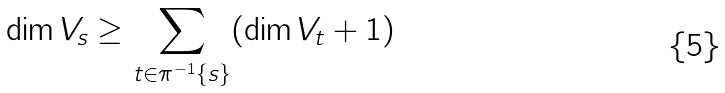<formula> <loc_0><loc_0><loc_500><loc_500>\dim V _ { s } \geq \sum _ { t \in \pi ^ { - 1 } \{ s \} } ( \dim V _ { t } + 1 )</formula> 